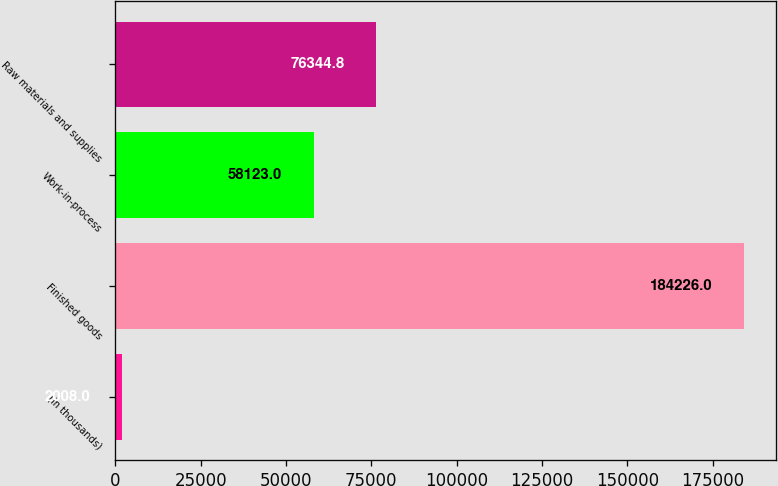<chart> <loc_0><loc_0><loc_500><loc_500><bar_chart><fcel>(in thousands)<fcel>Finished goods<fcel>Work-in-process<fcel>Raw materials and supplies<nl><fcel>2008<fcel>184226<fcel>58123<fcel>76344.8<nl></chart> 